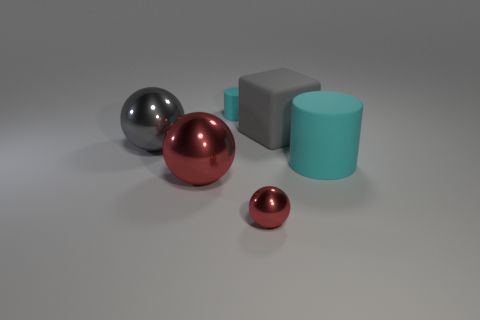Can you describe the different textures and shapes in the image? Absolutely. The image features a variety of geometric shapes including spheres and cubes. The textures vary among the objects as well, with some having a shiny, reflective surface which could be metallic, and others sporting a matte finish. Specifically, there's a large red reflective sphere, a smaller shiny silver sphere, and an even smaller matte red sphere. Additionally, there's a matte teal cylinder and a matte grey cube.  Which object stands out the most to you and why? The large red reflective sphere stands out the most. Its vibrant color and glossy surface catch the eye, creating highlights and reflections that make it visually prominent in contrast to the muted colors and matte textures of the other objects. 